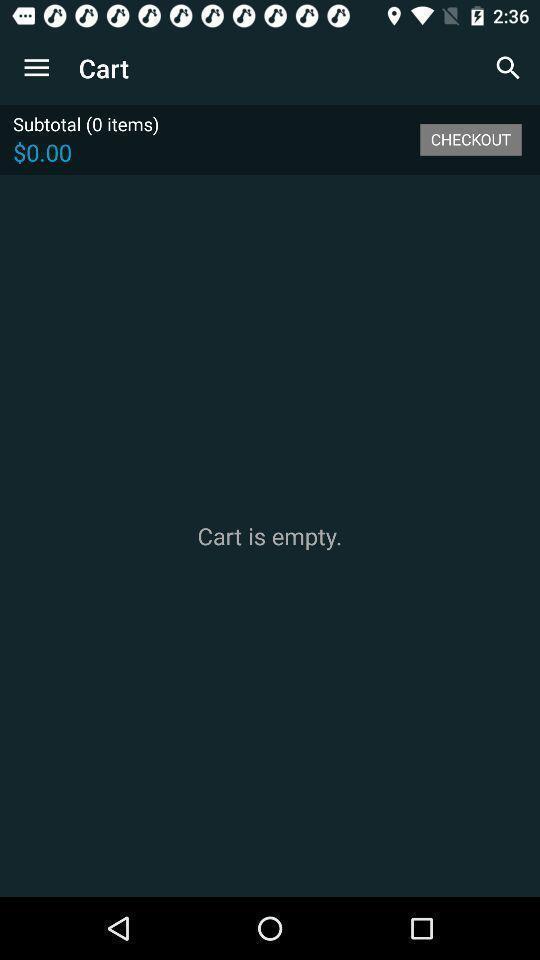Explain the elements present in this screenshot. Screen shows cart details in shopping app. 